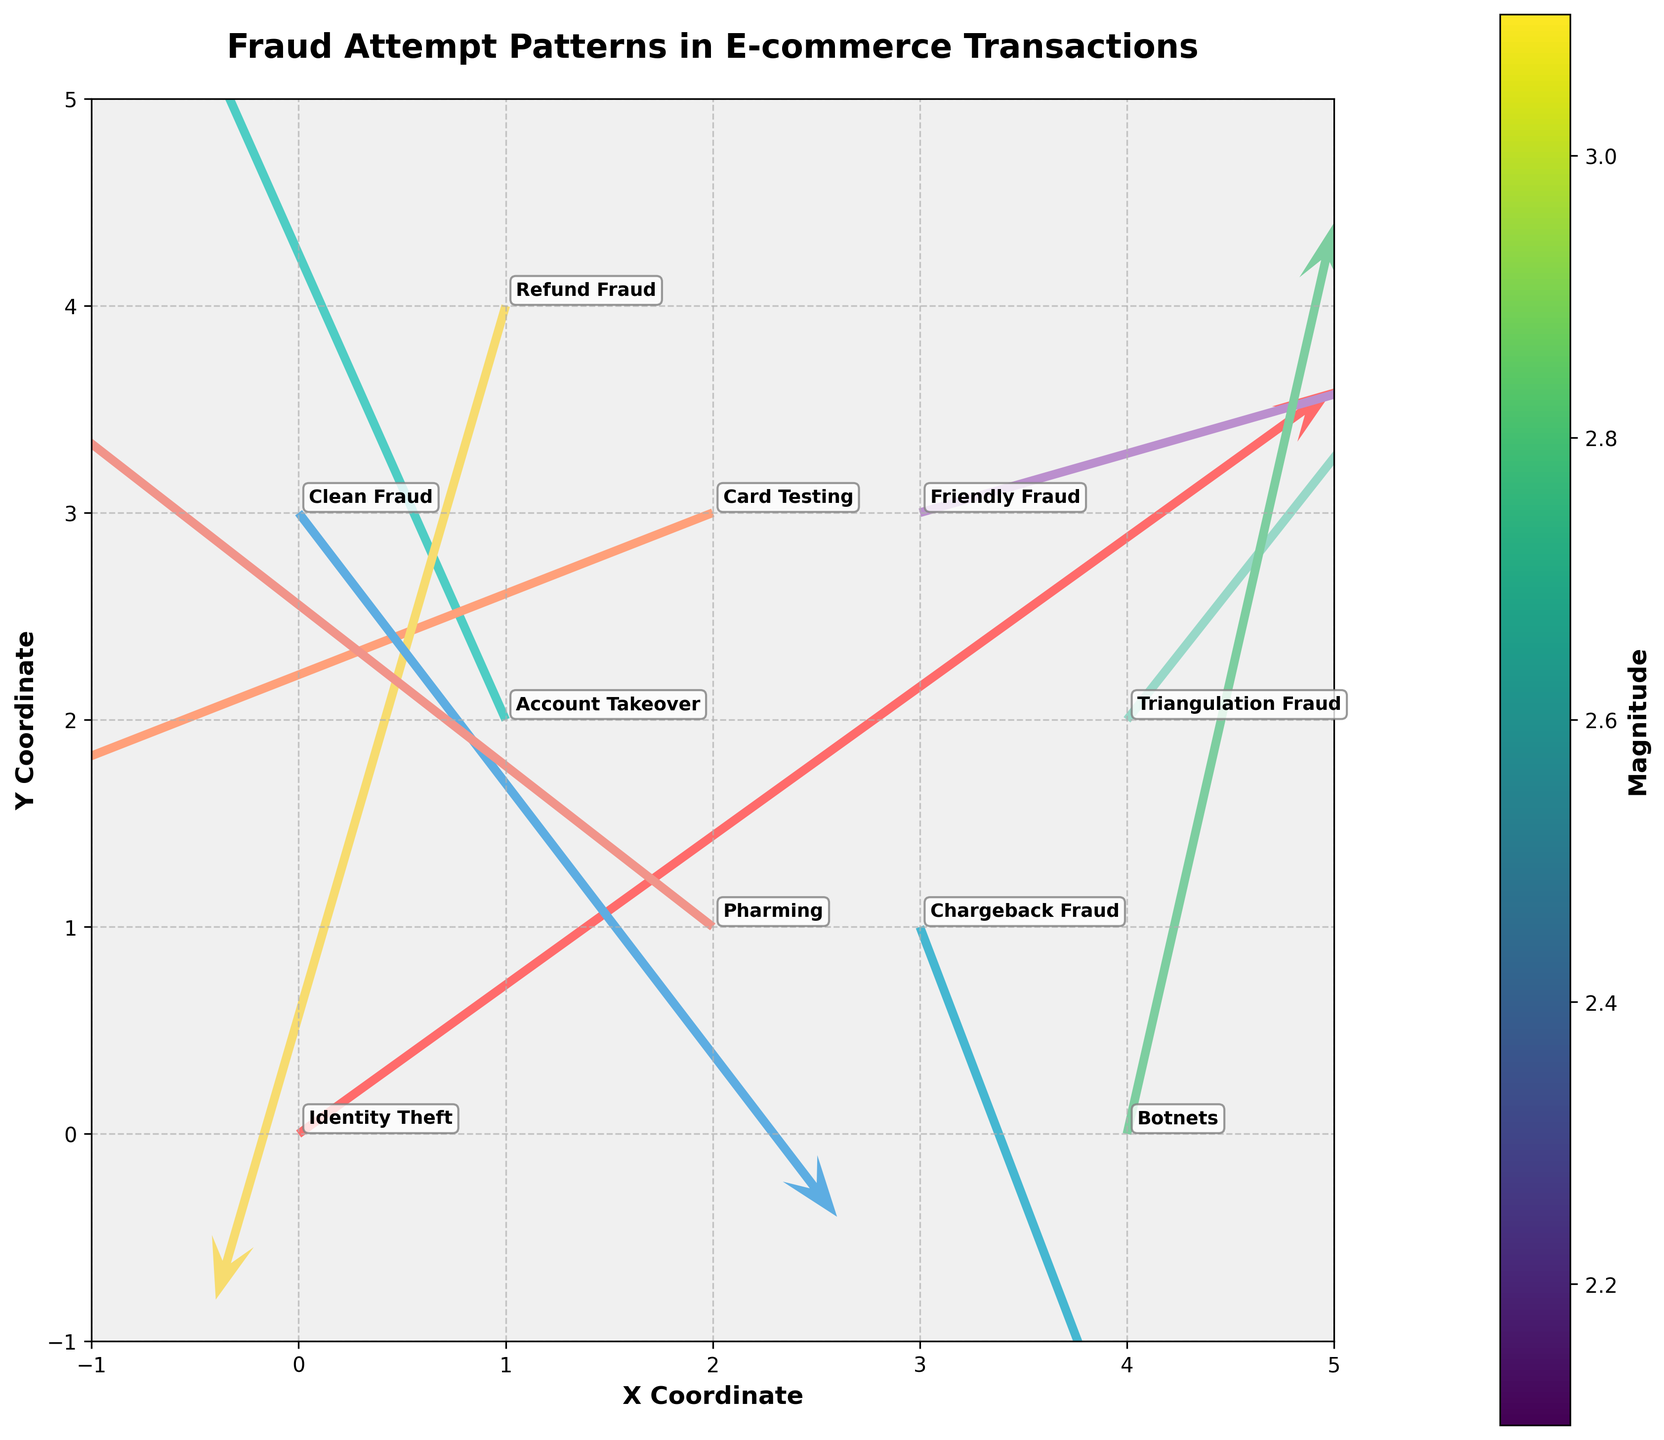What is the title of the plot? The plot displays the title at the top center. It reads "Fraud Attempt Patterns in E-commerce Transactions."
Answer: Fraud Attempt Patterns in E-commerce Transactions What are the coordinates of the arrow representing "Identity Theft"? By looking at the starting points labeled, the arrow for "Identity Theft" starts at coordinates (0, 0).
Answer: (0, 0) Which fraud type has the highest positive x-component? We need to identify the fraud type with the largest positive "u" value. The highest positive x-component is 2.5, corresponding to "Identity Theft."
Answer: Identity Theft What is the average magnitude of all fraud types? Sum all magnitudes (3.1 + 2.9 + 2.2 + 2.5 + 2.4 + 2.5 + 2.2 + 2.1 + 2.3 + 2.3) and divide by the number of fraud types (10). The average is (24.5 / 10) = 2.45.
Answer: 2.45 Which fraud types have a significant downward y-component? Check for arrows with notably negative "v" values. Both "Chargeback Fraud" and "Refund Fraud" have significantly negative y-components, with -2.1 and -2.4 respectively.
Answer: Chargeback Fraud, Refund Fraud Which arrows are colored the same, and why? The arrows’ colors are customized, not correlated with any variable. Multiple arrows share the same colors, such as "Botnets" and "Card Testing" sharing a shade of teal.
Answer: Botnets, Card Testing Which fraud type has the vector closest to a horizontal line? The vector closest to a horizontal line has the smallest magnitude of the vertical component "v" relative to "u." "Friendly Fraud" with a small y-component of 0.6 fits this description.
Answer: Friendly Fraud What types of fraud are associated with vectors pointing left? Inspect vectors with negative "u" values. "Account Takeover," "Card Testing," "Refund Fraud," and "Pharming" all have leftward vectors with negative x-components.
Answer: Account Takeover, Card Testing, Refund Fraud, Pharming Compare the magnitudes of "Botnets" and "Chargeback Fraud." Which is larger? "Botnets" has a magnitude of 2.3, while "Chargeback Fraud" has a magnitude of 2.2. Therefore, "Botnets" is slightly larger.
Answer: Botnets 